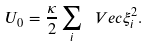Convert formula to latex. <formula><loc_0><loc_0><loc_500><loc_500>U _ { 0 } = \frac { \kappa } { 2 } \sum _ { i } \ V e c { \xi } _ { i } ^ { 2 } .</formula> 